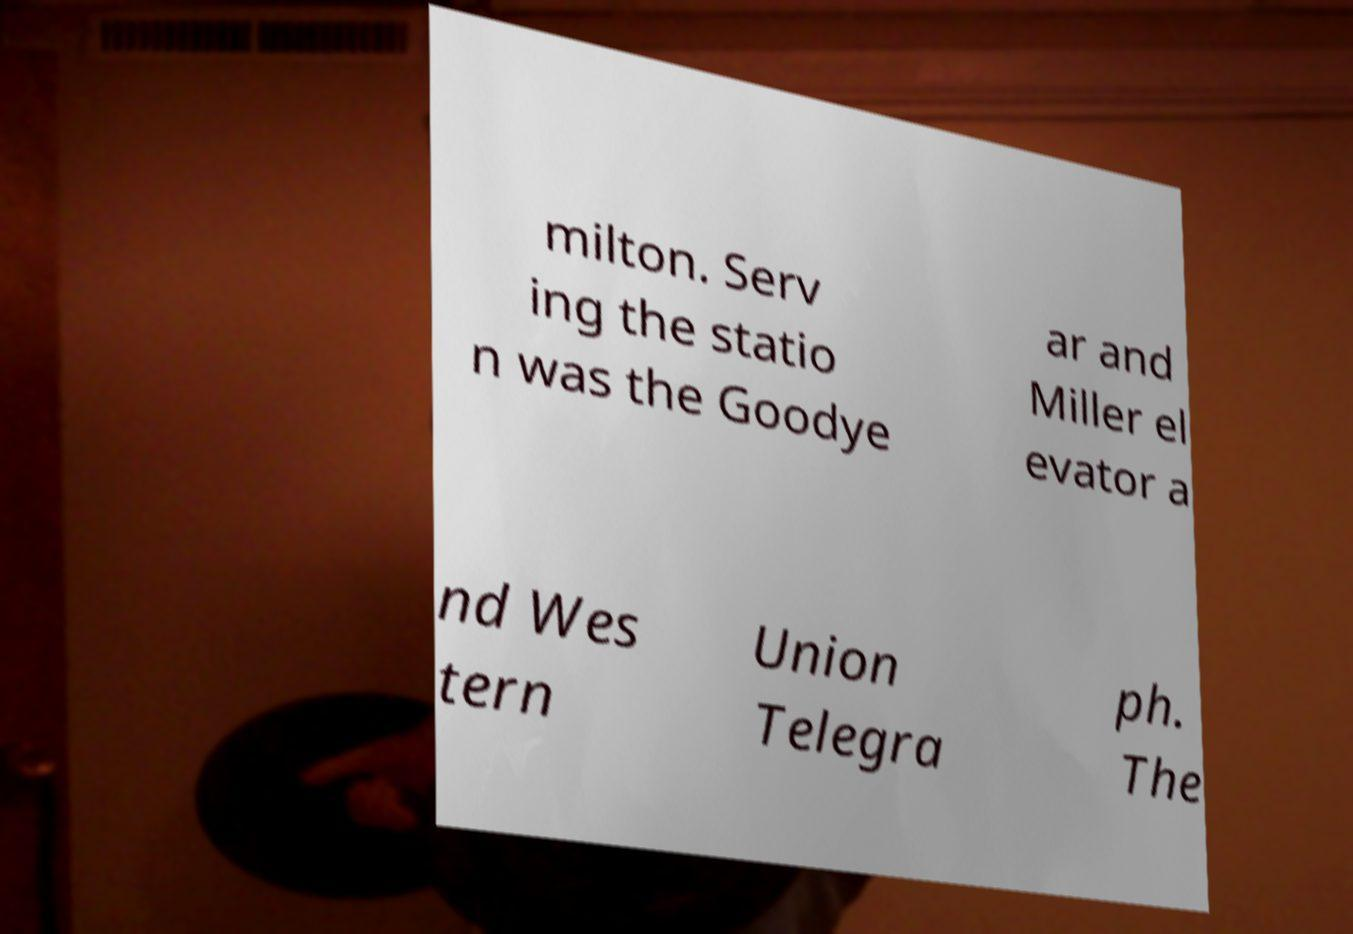For documentation purposes, I need the text within this image transcribed. Could you provide that? milton. Serv ing the statio n was the Goodye ar and Miller el evator a nd Wes tern Union Telegra ph. The 